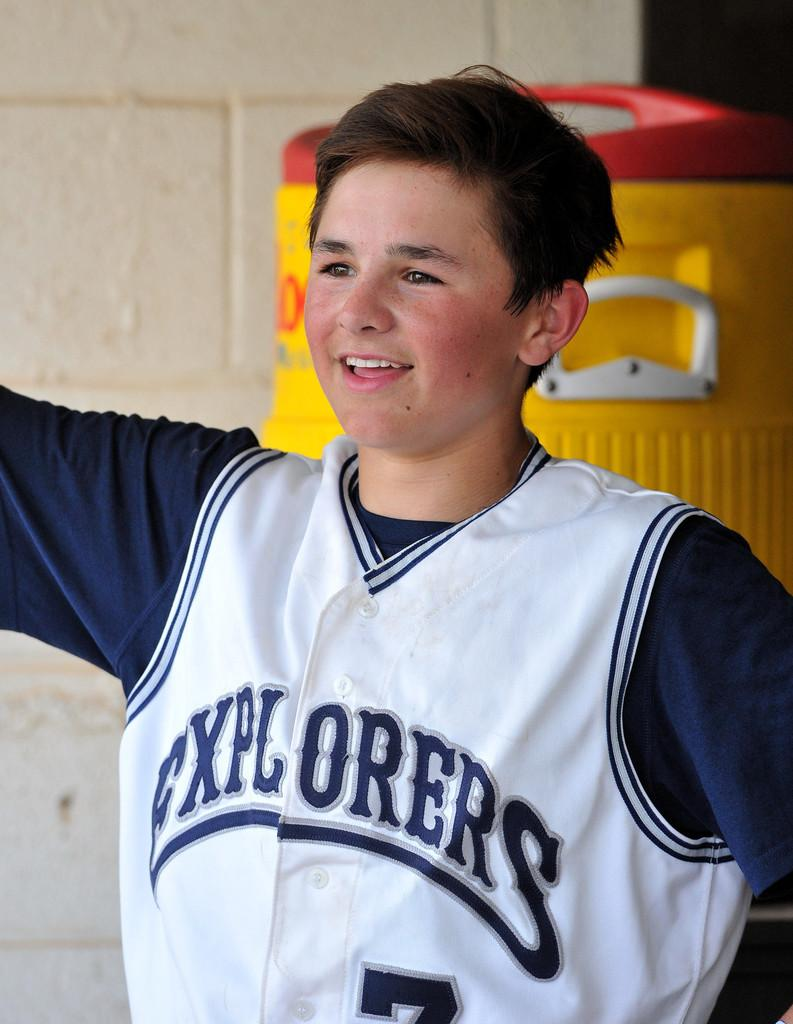<image>
Share a concise interpretation of the image provided. The jersey that the kid is wearing is for the team the Explorers 